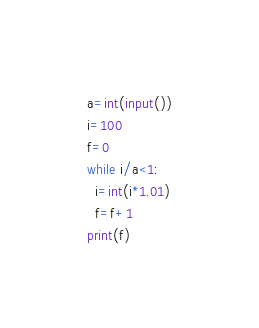Convert code to text. <code><loc_0><loc_0><loc_500><loc_500><_Python_>a=int(input())
i=100
f=0
while i/a<1:  
  i=int(i*1.01)
  f=f+1
print(f)</code> 